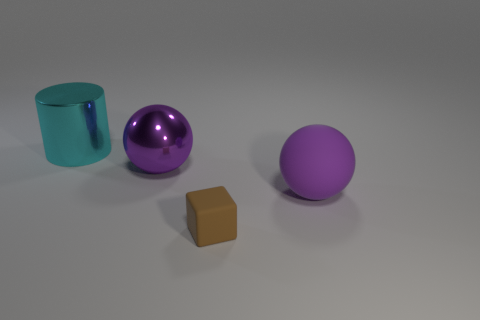Add 3 purple things. How many purple things exist? 5 Add 4 small cubes. How many objects exist? 8 Subtract 0 green cylinders. How many objects are left? 4 Subtract all cylinders. How many objects are left? 3 Subtract 1 cylinders. How many cylinders are left? 0 Subtract all cyan balls. Subtract all red cylinders. How many balls are left? 2 Subtract all tiny cubes. Subtract all big yellow matte objects. How many objects are left? 3 Add 1 large shiny balls. How many large shiny balls are left? 2 